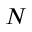<formula> <loc_0><loc_0><loc_500><loc_500>N</formula> 